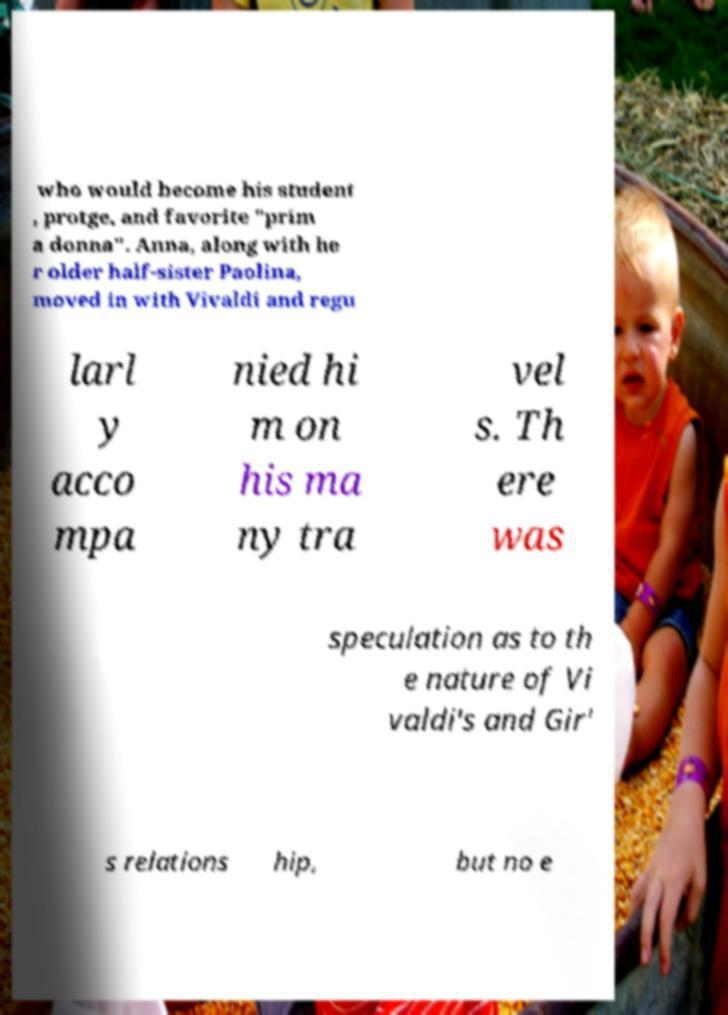For documentation purposes, I need the text within this image transcribed. Could you provide that? who would become his student , protge, and favorite "prim a donna". Anna, along with he r older half-sister Paolina, moved in with Vivaldi and regu larl y acco mpa nied hi m on his ma ny tra vel s. Th ere was speculation as to th e nature of Vi valdi's and Gir' s relations hip, but no e 